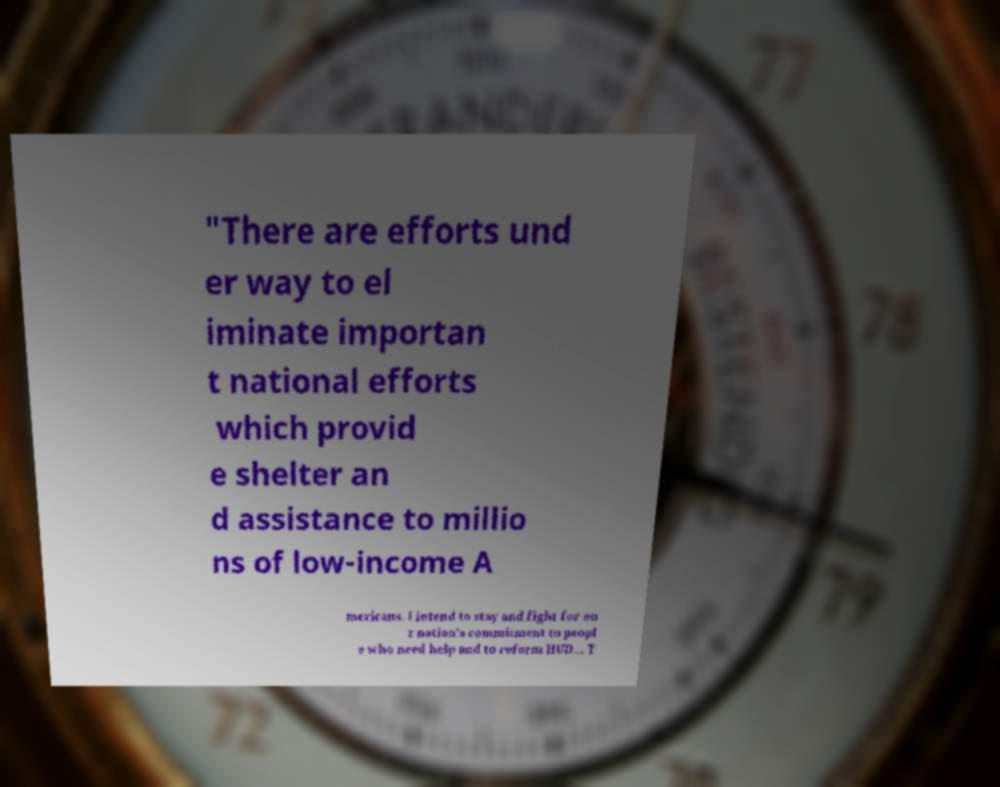Please read and relay the text visible in this image. What does it say? "There are efforts und er way to el iminate importan t national efforts which provid e shelter an d assistance to millio ns of low-income A mericans. I intend to stay and fight for ou r nation's commitment to peopl e who need help and to reform HUD... T 